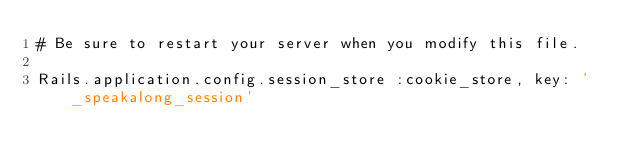Convert code to text. <code><loc_0><loc_0><loc_500><loc_500><_Ruby_># Be sure to restart your server when you modify this file.

Rails.application.config.session_store :cookie_store, key: '_speakalong_session'
</code> 